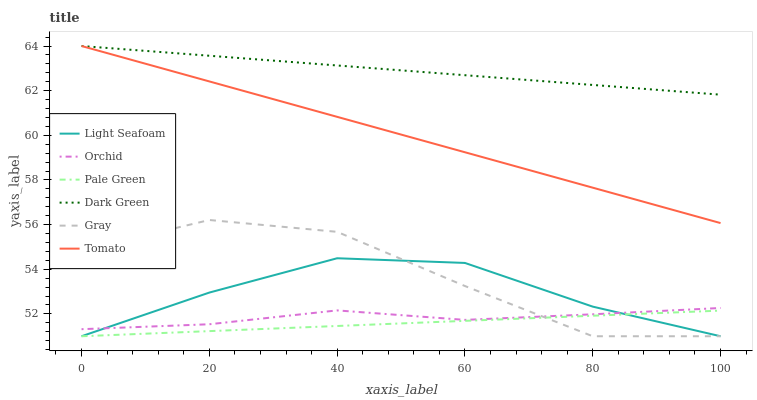Does Pale Green have the minimum area under the curve?
Answer yes or no. Yes. Does Dark Green have the maximum area under the curve?
Answer yes or no. Yes. Does Gray have the minimum area under the curve?
Answer yes or no. No. Does Gray have the maximum area under the curve?
Answer yes or no. No. Is Pale Green the smoothest?
Answer yes or no. Yes. Is Gray the roughest?
Answer yes or no. Yes. Is Orchid the smoothest?
Answer yes or no. No. Is Orchid the roughest?
Answer yes or no. No. Does Gray have the lowest value?
Answer yes or no. Yes. Does Orchid have the lowest value?
Answer yes or no. No. Does Dark Green have the highest value?
Answer yes or no. Yes. Does Gray have the highest value?
Answer yes or no. No. Is Light Seafoam less than Dark Green?
Answer yes or no. Yes. Is Dark Green greater than Orchid?
Answer yes or no. Yes. Does Gray intersect Orchid?
Answer yes or no. Yes. Is Gray less than Orchid?
Answer yes or no. No. Is Gray greater than Orchid?
Answer yes or no. No. Does Light Seafoam intersect Dark Green?
Answer yes or no. No. 